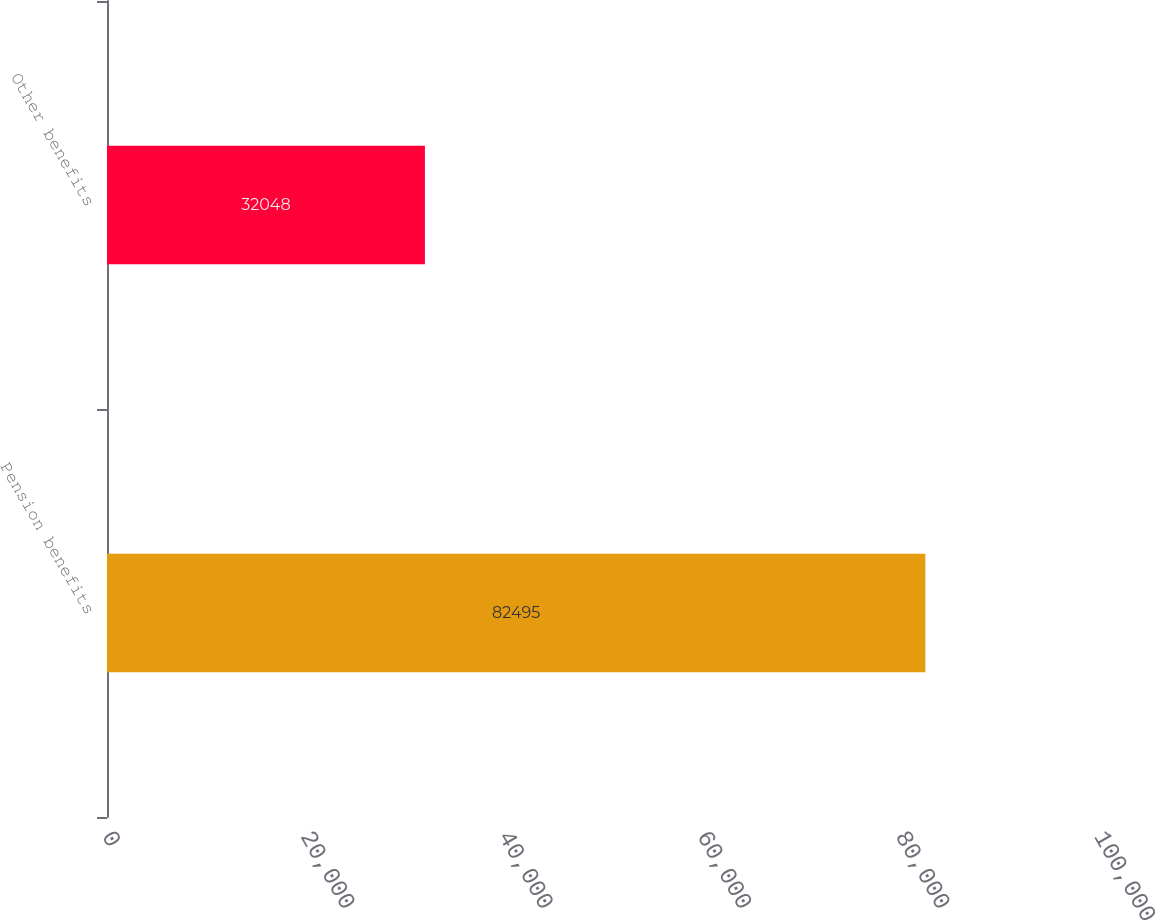Convert chart. <chart><loc_0><loc_0><loc_500><loc_500><bar_chart><fcel>Pension benefits<fcel>Other benefits<nl><fcel>82495<fcel>32048<nl></chart> 